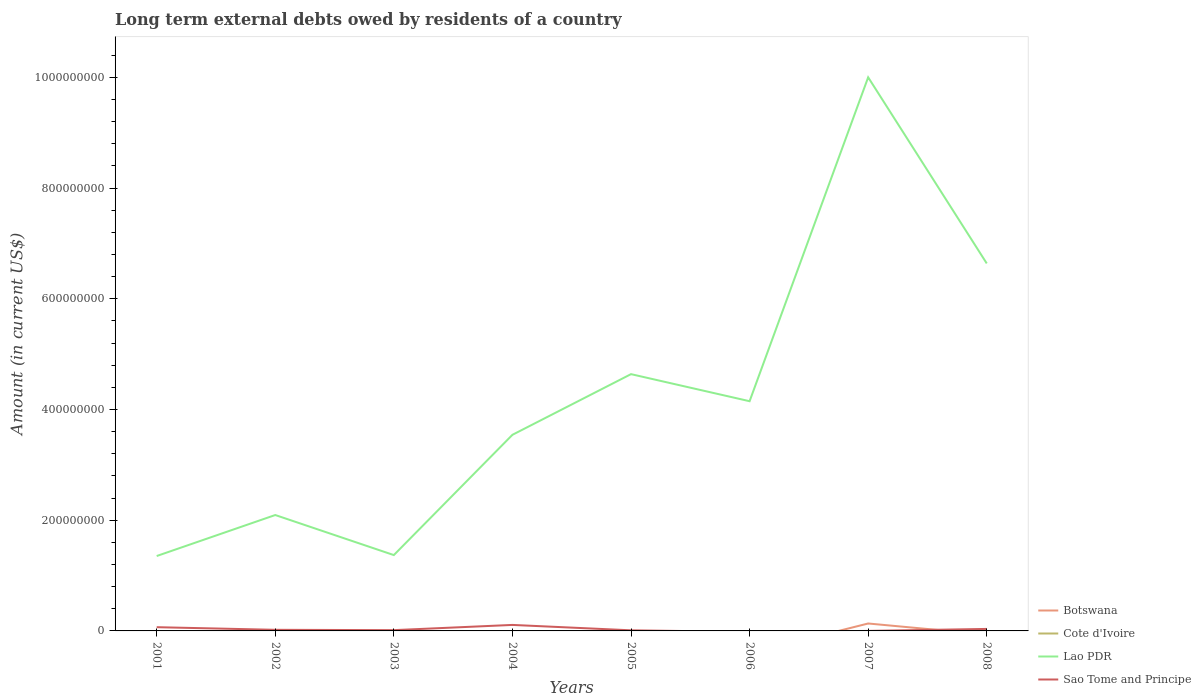Does the line corresponding to Botswana intersect with the line corresponding to Lao PDR?
Give a very brief answer. No. Is the number of lines equal to the number of legend labels?
Your answer should be very brief. No. Across all years, what is the maximum amount of long-term external debts owed by residents in Lao PDR?
Your answer should be compact. 1.35e+08. What is the total amount of long-term external debts owed by residents in Lao PDR in the graph?
Provide a short and direct response. -4.55e+08. What is the difference between the highest and the second highest amount of long-term external debts owed by residents in Botswana?
Your response must be concise. 1.34e+07. What is the difference between the highest and the lowest amount of long-term external debts owed by residents in Botswana?
Provide a short and direct response. 1. How many lines are there?
Ensure brevity in your answer.  3. How many years are there in the graph?
Provide a succinct answer. 8. Are the values on the major ticks of Y-axis written in scientific E-notation?
Your answer should be very brief. No. Where does the legend appear in the graph?
Offer a very short reply. Bottom right. How many legend labels are there?
Offer a terse response. 4. What is the title of the graph?
Your answer should be compact. Long term external debts owed by residents of a country. What is the Amount (in current US$) of Cote d'Ivoire in 2001?
Offer a very short reply. 0. What is the Amount (in current US$) in Lao PDR in 2001?
Your response must be concise. 1.35e+08. What is the Amount (in current US$) of Sao Tome and Principe in 2001?
Your answer should be very brief. 6.73e+06. What is the Amount (in current US$) of Cote d'Ivoire in 2002?
Provide a short and direct response. 0. What is the Amount (in current US$) in Lao PDR in 2002?
Offer a terse response. 2.09e+08. What is the Amount (in current US$) in Sao Tome and Principe in 2002?
Offer a very short reply. 2.02e+06. What is the Amount (in current US$) of Botswana in 2003?
Your response must be concise. 0. What is the Amount (in current US$) of Cote d'Ivoire in 2003?
Offer a very short reply. 0. What is the Amount (in current US$) of Lao PDR in 2003?
Give a very brief answer. 1.37e+08. What is the Amount (in current US$) of Sao Tome and Principe in 2003?
Ensure brevity in your answer.  1.40e+06. What is the Amount (in current US$) of Lao PDR in 2004?
Keep it short and to the point. 3.54e+08. What is the Amount (in current US$) in Sao Tome and Principe in 2004?
Make the answer very short. 1.08e+07. What is the Amount (in current US$) of Cote d'Ivoire in 2005?
Your answer should be compact. 0. What is the Amount (in current US$) in Lao PDR in 2005?
Offer a very short reply. 4.64e+08. What is the Amount (in current US$) of Sao Tome and Principe in 2005?
Offer a very short reply. 1.11e+06. What is the Amount (in current US$) of Cote d'Ivoire in 2006?
Your answer should be very brief. 0. What is the Amount (in current US$) of Lao PDR in 2006?
Your response must be concise. 4.15e+08. What is the Amount (in current US$) of Botswana in 2007?
Provide a succinct answer. 1.34e+07. What is the Amount (in current US$) in Cote d'Ivoire in 2007?
Your answer should be compact. 0. What is the Amount (in current US$) of Lao PDR in 2007?
Your response must be concise. 1.00e+09. What is the Amount (in current US$) of Sao Tome and Principe in 2007?
Your answer should be compact. 1.70e+04. What is the Amount (in current US$) of Cote d'Ivoire in 2008?
Provide a succinct answer. 0. What is the Amount (in current US$) in Lao PDR in 2008?
Offer a very short reply. 6.64e+08. What is the Amount (in current US$) in Sao Tome and Principe in 2008?
Offer a very short reply. 3.61e+06. Across all years, what is the maximum Amount (in current US$) of Botswana?
Offer a terse response. 1.34e+07. Across all years, what is the maximum Amount (in current US$) in Lao PDR?
Provide a short and direct response. 1.00e+09. Across all years, what is the maximum Amount (in current US$) of Sao Tome and Principe?
Your answer should be very brief. 1.08e+07. Across all years, what is the minimum Amount (in current US$) of Lao PDR?
Provide a succinct answer. 1.35e+08. What is the total Amount (in current US$) in Botswana in the graph?
Offer a terse response. 1.34e+07. What is the total Amount (in current US$) in Lao PDR in the graph?
Make the answer very short. 3.38e+09. What is the total Amount (in current US$) in Sao Tome and Principe in the graph?
Offer a very short reply. 2.57e+07. What is the difference between the Amount (in current US$) of Lao PDR in 2001 and that in 2002?
Ensure brevity in your answer.  -7.41e+07. What is the difference between the Amount (in current US$) of Sao Tome and Principe in 2001 and that in 2002?
Ensure brevity in your answer.  4.72e+06. What is the difference between the Amount (in current US$) of Lao PDR in 2001 and that in 2003?
Make the answer very short. -1.69e+06. What is the difference between the Amount (in current US$) of Sao Tome and Principe in 2001 and that in 2003?
Your answer should be compact. 5.33e+06. What is the difference between the Amount (in current US$) in Lao PDR in 2001 and that in 2004?
Ensure brevity in your answer.  -2.19e+08. What is the difference between the Amount (in current US$) of Sao Tome and Principe in 2001 and that in 2004?
Offer a terse response. -4.11e+06. What is the difference between the Amount (in current US$) of Lao PDR in 2001 and that in 2005?
Your answer should be compact. -3.29e+08. What is the difference between the Amount (in current US$) in Sao Tome and Principe in 2001 and that in 2005?
Ensure brevity in your answer.  5.62e+06. What is the difference between the Amount (in current US$) of Lao PDR in 2001 and that in 2006?
Your answer should be very brief. -2.80e+08. What is the difference between the Amount (in current US$) of Lao PDR in 2001 and that in 2007?
Offer a terse response. -8.65e+08. What is the difference between the Amount (in current US$) of Sao Tome and Principe in 2001 and that in 2007?
Make the answer very short. 6.72e+06. What is the difference between the Amount (in current US$) of Lao PDR in 2001 and that in 2008?
Offer a terse response. -5.29e+08. What is the difference between the Amount (in current US$) of Sao Tome and Principe in 2001 and that in 2008?
Your response must be concise. 3.12e+06. What is the difference between the Amount (in current US$) in Lao PDR in 2002 and that in 2003?
Offer a terse response. 7.24e+07. What is the difference between the Amount (in current US$) in Sao Tome and Principe in 2002 and that in 2003?
Offer a very short reply. 6.16e+05. What is the difference between the Amount (in current US$) of Lao PDR in 2002 and that in 2004?
Provide a short and direct response. -1.45e+08. What is the difference between the Amount (in current US$) of Sao Tome and Principe in 2002 and that in 2004?
Provide a succinct answer. -8.82e+06. What is the difference between the Amount (in current US$) in Lao PDR in 2002 and that in 2005?
Offer a very short reply. -2.55e+08. What is the difference between the Amount (in current US$) in Sao Tome and Principe in 2002 and that in 2005?
Ensure brevity in your answer.  9.07e+05. What is the difference between the Amount (in current US$) in Lao PDR in 2002 and that in 2006?
Your answer should be very brief. -2.06e+08. What is the difference between the Amount (in current US$) in Lao PDR in 2002 and that in 2007?
Keep it short and to the point. -7.91e+08. What is the difference between the Amount (in current US$) in Sao Tome and Principe in 2002 and that in 2007?
Offer a terse response. 2.00e+06. What is the difference between the Amount (in current US$) of Lao PDR in 2002 and that in 2008?
Offer a very short reply. -4.55e+08. What is the difference between the Amount (in current US$) in Sao Tome and Principe in 2002 and that in 2008?
Make the answer very short. -1.59e+06. What is the difference between the Amount (in current US$) of Lao PDR in 2003 and that in 2004?
Offer a very short reply. -2.17e+08. What is the difference between the Amount (in current US$) in Sao Tome and Principe in 2003 and that in 2004?
Your response must be concise. -9.44e+06. What is the difference between the Amount (in current US$) in Lao PDR in 2003 and that in 2005?
Provide a succinct answer. -3.27e+08. What is the difference between the Amount (in current US$) in Sao Tome and Principe in 2003 and that in 2005?
Your answer should be very brief. 2.91e+05. What is the difference between the Amount (in current US$) in Lao PDR in 2003 and that in 2006?
Offer a very short reply. -2.78e+08. What is the difference between the Amount (in current US$) of Lao PDR in 2003 and that in 2007?
Your response must be concise. -8.63e+08. What is the difference between the Amount (in current US$) of Sao Tome and Principe in 2003 and that in 2007?
Keep it short and to the point. 1.38e+06. What is the difference between the Amount (in current US$) in Lao PDR in 2003 and that in 2008?
Your response must be concise. -5.27e+08. What is the difference between the Amount (in current US$) in Sao Tome and Principe in 2003 and that in 2008?
Your answer should be very brief. -2.21e+06. What is the difference between the Amount (in current US$) of Lao PDR in 2004 and that in 2005?
Your answer should be very brief. -1.10e+08. What is the difference between the Amount (in current US$) of Sao Tome and Principe in 2004 and that in 2005?
Your response must be concise. 9.73e+06. What is the difference between the Amount (in current US$) of Lao PDR in 2004 and that in 2006?
Give a very brief answer. -6.07e+07. What is the difference between the Amount (in current US$) in Lao PDR in 2004 and that in 2007?
Your answer should be compact. -6.46e+08. What is the difference between the Amount (in current US$) of Sao Tome and Principe in 2004 and that in 2007?
Ensure brevity in your answer.  1.08e+07. What is the difference between the Amount (in current US$) of Lao PDR in 2004 and that in 2008?
Keep it short and to the point. -3.10e+08. What is the difference between the Amount (in current US$) in Sao Tome and Principe in 2004 and that in 2008?
Ensure brevity in your answer.  7.23e+06. What is the difference between the Amount (in current US$) of Lao PDR in 2005 and that in 2006?
Your response must be concise. 4.89e+07. What is the difference between the Amount (in current US$) in Lao PDR in 2005 and that in 2007?
Offer a very short reply. -5.36e+08. What is the difference between the Amount (in current US$) in Sao Tome and Principe in 2005 and that in 2007?
Give a very brief answer. 1.09e+06. What is the difference between the Amount (in current US$) in Lao PDR in 2005 and that in 2008?
Make the answer very short. -2.00e+08. What is the difference between the Amount (in current US$) in Sao Tome and Principe in 2005 and that in 2008?
Ensure brevity in your answer.  -2.50e+06. What is the difference between the Amount (in current US$) in Lao PDR in 2006 and that in 2007?
Your response must be concise. -5.85e+08. What is the difference between the Amount (in current US$) of Lao PDR in 2006 and that in 2008?
Your answer should be very brief. -2.49e+08. What is the difference between the Amount (in current US$) of Lao PDR in 2007 and that in 2008?
Provide a succinct answer. 3.36e+08. What is the difference between the Amount (in current US$) of Sao Tome and Principe in 2007 and that in 2008?
Provide a short and direct response. -3.59e+06. What is the difference between the Amount (in current US$) in Lao PDR in 2001 and the Amount (in current US$) in Sao Tome and Principe in 2002?
Your answer should be compact. 1.33e+08. What is the difference between the Amount (in current US$) of Lao PDR in 2001 and the Amount (in current US$) of Sao Tome and Principe in 2003?
Provide a succinct answer. 1.34e+08. What is the difference between the Amount (in current US$) in Lao PDR in 2001 and the Amount (in current US$) in Sao Tome and Principe in 2004?
Offer a very short reply. 1.24e+08. What is the difference between the Amount (in current US$) in Lao PDR in 2001 and the Amount (in current US$) in Sao Tome and Principe in 2005?
Provide a short and direct response. 1.34e+08. What is the difference between the Amount (in current US$) of Lao PDR in 2001 and the Amount (in current US$) of Sao Tome and Principe in 2007?
Your answer should be very brief. 1.35e+08. What is the difference between the Amount (in current US$) in Lao PDR in 2001 and the Amount (in current US$) in Sao Tome and Principe in 2008?
Your answer should be compact. 1.32e+08. What is the difference between the Amount (in current US$) of Lao PDR in 2002 and the Amount (in current US$) of Sao Tome and Principe in 2003?
Offer a very short reply. 2.08e+08. What is the difference between the Amount (in current US$) of Lao PDR in 2002 and the Amount (in current US$) of Sao Tome and Principe in 2004?
Keep it short and to the point. 1.99e+08. What is the difference between the Amount (in current US$) of Lao PDR in 2002 and the Amount (in current US$) of Sao Tome and Principe in 2005?
Offer a very short reply. 2.08e+08. What is the difference between the Amount (in current US$) in Lao PDR in 2002 and the Amount (in current US$) in Sao Tome and Principe in 2007?
Offer a very short reply. 2.09e+08. What is the difference between the Amount (in current US$) in Lao PDR in 2002 and the Amount (in current US$) in Sao Tome and Principe in 2008?
Ensure brevity in your answer.  2.06e+08. What is the difference between the Amount (in current US$) in Lao PDR in 2003 and the Amount (in current US$) in Sao Tome and Principe in 2004?
Your answer should be compact. 1.26e+08. What is the difference between the Amount (in current US$) of Lao PDR in 2003 and the Amount (in current US$) of Sao Tome and Principe in 2005?
Provide a short and direct response. 1.36e+08. What is the difference between the Amount (in current US$) of Lao PDR in 2003 and the Amount (in current US$) of Sao Tome and Principe in 2007?
Provide a succinct answer. 1.37e+08. What is the difference between the Amount (in current US$) in Lao PDR in 2003 and the Amount (in current US$) in Sao Tome and Principe in 2008?
Offer a very short reply. 1.33e+08. What is the difference between the Amount (in current US$) of Lao PDR in 2004 and the Amount (in current US$) of Sao Tome and Principe in 2005?
Ensure brevity in your answer.  3.53e+08. What is the difference between the Amount (in current US$) of Lao PDR in 2004 and the Amount (in current US$) of Sao Tome and Principe in 2007?
Your response must be concise. 3.54e+08. What is the difference between the Amount (in current US$) in Lao PDR in 2004 and the Amount (in current US$) in Sao Tome and Principe in 2008?
Your answer should be compact. 3.51e+08. What is the difference between the Amount (in current US$) in Lao PDR in 2005 and the Amount (in current US$) in Sao Tome and Principe in 2007?
Ensure brevity in your answer.  4.64e+08. What is the difference between the Amount (in current US$) of Lao PDR in 2005 and the Amount (in current US$) of Sao Tome and Principe in 2008?
Keep it short and to the point. 4.60e+08. What is the difference between the Amount (in current US$) of Lao PDR in 2006 and the Amount (in current US$) of Sao Tome and Principe in 2007?
Keep it short and to the point. 4.15e+08. What is the difference between the Amount (in current US$) of Lao PDR in 2006 and the Amount (in current US$) of Sao Tome and Principe in 2008?
Keep it short and to the point. 4.11e+08. What is the difference between the Amount (in current US$) of Botswana in 2007 and the Amount (in current US$) of Lao PDR in 2008?
Ensure brevity in your answer.  -6.50e+08. What is the difference between the Amount (in current US$) in Botswana in 2007 and the Amount (in current US$) in Sao Tome and Principe in 2008?
Offer a terse response. 9.81e+06. What is the difference between the Amount (in current US$) in Lao PDR in 2007 and the Amount (in current US$) in Sao Tome and Principe in 2008?
Give a very brief answer. 9.97e+08. What is the average Amount (in current US$) in Botswana per year?
Your answer should be compact. 1.68e+06. What is the average Amount (in current US$) in Cote d'Ivoire per year?
Ensure brevity in your answer.  0. What is the average Amount (in current US$) of Lao PDR per year?
Provide a succinct answer. 4.22e+08. What is the average Amount (in current US$) in Sao Tome and Principe per year?
Make the answer very short. 3.21e+06. In the year 2001, what is the difference between the Amount (in current US$) in Lao PDR and Amount (in current US$) in Sao Tome and Principe?
Provide a short and direct response. 1.29e+08. In the year 2002, what is the difference between the Amount (in current US$) of Lao PDR and Amount (in current US$) of Sao Tome and Principe?
Provide a succinct answer. 2.07e+08. In the year 2003, what is the difference between the Amount (in current US$) of Lao PDR and Amount (in current US$) of Sao Tome and Principe?
Offer a terse response. 1.36e+08. In the year 2004, what is the difference between the Amount (in current US$) of Lao PDR and Amount (in current US$) of Sao Tome and Principe?
Make the answer very short. 3.43e+08. In the year 2005, what is the difference between the Amount (in current US$) in Lao PDR and Amount (in current US$) in Sao Tome and Principe?
Offer a very short reply. 4.63e+08. In the year 2007, what is the difference between the Amount (in current US$) of Botswana and Amount (in current US$) of Lao PDR?
Give a very brief answer. -9.87e+08. In the year 2007, what is the difference between the Amount (in current US$) in Botswana and Amount (in current US$) in Sao Tome and Principe?
Your answer should be compact. 1.34e+07. In the year 2007, what is the difference between the Amount (in current US$) in Lao PDR and Amount (in current US$) in Sao Tome and Principe?
Provide a short and direct response. 1.00e+09. In the year 2008, what is the difference between the Amount (in current US$) in Lao PDR and Amount (in current US$) in Sao Tome and Principe?
Give a very brief answer. 6.60e+08. What is the ratio of the Amount (in current US$) in Lao PDR in 2001 to that in 2002?
Offer a very short reply. 0.65. What is the ratio of the Amount (in current US$) of Sao Tome and Principe in 2001 to that in 2002?
Provide a short and direct response. 3.34. What is the ratio of the Amount (in current US$) of Lao PDR in 2001 to that in 2003?
Provide a succinct answer. 0.99. What is the ratio of the Amount (in current US$) of Sao Tome and Principe in 2001 to that in 2003?
Your answer should be very brief. 4.81. What is the ratio of the Amount (in current US$) of Lao PDR in 2001 to that in 2004?
Make the answer very short. 0.38. What is the ratio of the Amount (in current US$) in Sao Tome and Principe in 2001 to that in 2004?
Make the answer very short. 0.62. What is the ratio of the Amount (in current US$) of Lao PDR in 2001 to that in 2005?
Keep it short and to the point. 0.29. What is the ratio of the Amount (in current US$) of Sao Tome and Principe in 2001 to that in 2005?
Your answer should be compact. 6.08. What is the ratio of the Amount (in current US$) in Lao PDR in 2001 to that in 2006?
Give a very brief answer. 0.33. What is the ratio of the Amount (in current US$) in Lao PDR in 2001 to that in 2007?
Make the answer very short. 0.14. What is the ratio of the Amount (in current US$) in Sao Tome and Principe in 2001 to that in 2007?
Provide a short and direct response. 396. What is the ratio of the Amount (in current US$) of Lao PDR in 2001 to that in 2008?
Provide a short and direct response. 0.2. What is the ratio of the Amount (in current US$) of Sao Tome and Principe in 2001 to that in 2008?
Provide a short and direct response. 1.87. What is the ratio of the Amount (in current US$) in Lao PDR in 2002 to that in 2003?
Keep it short and to the point. 1.53. What is the ratio of the Amount (in current US$) in Sao Tome and Principe in 2002 to that in 2003?
Your response must be concise. 1.44. What is the ratio of the Amount (in current US$) of Lao PDR in 2002 to that in 2004?
Ensure brevity in your answer.  0.59. What is the ratio of the Amount (in current US$) in Sao Tome and Principe in 2002 to that in 2004?
Keep it short and to the point. 0.19. What is the ratio of the Amount (in current US$) of Lao PDR in 2002 to that in 2005?
Give a very brief answer. 0.45. What is the ratio of the Amount (in current US$) in Sao Tome and Principe in 2002 to that in 2005?
Your answer should be compact. 1.82. What is the ratio of the Amount (in current US$) of Lao PDR in 2002 to that in 2006?
Provide a succinct answer. 0.5. What is the ratio of the Amount (in current US$) of Lao PDR in 2002 to that in 2007?
Your response must be concise. 0.21. What is the ratio of the Amount (in current US$) of Sao Tome and Principe in 2002 to that in 2007?
Your answer should be compact. 118.53. What is the ratio of the Amount (in current US$) in Lao PDR in 2002 to that in 2008?
Offer a very short reply. 0.32. What is the ratio of the Amount (in current US$) in Sao Tome and Principe in 2002 to that in 2008?
Offer a terse response. 0.56. What is the ratio of the Amount (in current US$) in Lao PDR in 2003 to that in 2004?
Give a very brief answer. 0.39. What is the ratio of the Amount (in current US$) in Sao Tome and Principe in 2003 to that in 2004?
Give a very brief answer. 0.13. What is the ratio of the Amount (in current US$) of Lao PDR in 2003 to that in 2005?
Your answer should be very brief. 0.3. What is the ratio of the Amount (in current US$) of Sao Tome and Principe in 2003 to that in 2005?
Provide a succinct answer. 1.26. What is the ratio of the Amount (in current US$) in Lao PDR in 2003 to that in 2006?
Your answer should be compact. 0.33. What is the ratio of the Amount (in current US$) of Lao PDR in 2003 to that in 2007?
Your response must be concise. 0.14. What is the ratio of the Amount (in current US$) in Sao Tome and Principe in 2003 to that in 2007?
Make the answer very short. 82.29. What is the ratio of the Amount (in current US$) of Lao PDR in 2003 to that in 2008?
Offer a very short reply. 0.21. What is the ratio of the Amount (in current US$) of Sao Tome and Principe in 2003 to that in 2008?
Give a very brief answer. 0.39. What is the ratio of the Amount (in current US$) in Lao PDR in 2004 to that in 2005?
Provide a succinct answer. 0.76. What is the ratio of the Amount (in current US$) in Sao Tome and Principe in 2004 to that in 2005?
Provide a succinct answer. 9.78. What is the ratio of the Amount (in current US$) in Lao PDR in 2004 to that in 2006?
Your response must be concise. 0.85. What is the ratio of the Amount (in current US$) in Lao PDR in 2004 to that in 2007?
Your response must be concise. 0.35. What is the ratio of the Amount (in current US$) of Sao Tome and Principe in 2004 to that in 2007?
Provide a short and direct response. 637.65. What is the ratio of the Amount (in current US$) of Lao PDR in 2004 to that in 2008?
Make the answer very short. 0.53. What is the ratio of the Amount (in current US$) of Sao Tome and Principe in 2004 to that in 2008?
Provide a short and direct response. 3. What is the ratio of the Amount (in current US$) in Lao PDR in 2005 to that in 2006?
Keep it short and to the point. 1.12. What is the ratio of the Amount (in current US$) of Lao PDR in 2005 to that in 2007?
Your answer should be compact. 0.46. What is the ratio of the Amount (in current US$) of Sao Tome and Principe in 2005 to that in 2007?
Keep it short and to the point. 65.18. What is the ratio of the Amount (in current US$) of Lao PDR in 2005 to that in 2008?
Offer a terse response. 0.7. What is the ratio of the Amount (in current US$) in Sao Tome and Principe in 2005 to that in 2008?
Your answer should be very brief. 0.31. What is the ratio of the Amount (in current US$) of Lao PDR in 2006 to that in 2007?
Make the answer very short. 0.41. What is the ratio of the Amount (in current US$) in Lao PDR in 2006 to that in 2008?
Ensure brevity in your answer.  0.63. What is the ratio of the Amount (in current US$) in Lao PDR in 2007 to that in 2008?
Give a very brief answer. 1.51. What is the ratio of the Amount (in current US$) in Sao Tome and Principe in 2007 to that in 2008?
Keep it short and to the point. 0. What is the difference between the highest and the second highest Amount (in current US$) in Lao PDR?
Keep it short and to the point. 3.36e+08. What is the difference between the highest and the second highest Amount (in current US$) in Sao Tome and Principe?
Provide a short and direct response. 4.11e+06. What is the difference between the highest and the lowest Amount (in current US$) in Botswana?
Your answer should be compact. 1.34e+07. What is the difference between the highest and the lowest Amount (in current US$) in Lao PDR?
Ensure brevity in your answer.  8.65e+08. What is the difference between the highest and the lowest Amount (in current US$) in Sao Tome and Principe?
Offer a terse response. 1.08e+07. 